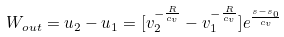Convert formula to latex. <formula><loc_0><loc_0><loc_500><loc_500>W _ { o u t } = u _ { 2 } - u _ { 1 } = [ v _ { 2 } ^ { - \frac { R } { c _ { v } } } - v _ { 1 } ^ { - \frac { R } { c _ { v } } } ] e ^ { \frac { s - s _ { 0 } } { c _ { v } } }</formula> 